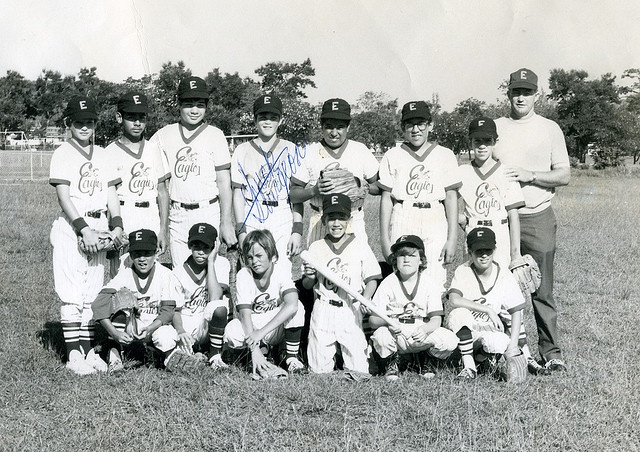Describe the objects in this image and their specific colors. I can see people in white, darkgray, gray, and black tones, people in white, lightgray, gray, darkgray, and black tones, people in white, darkgray, black, and gray tones, people in white, darkgray, black, and gray tones, and people in white, darkgray, black, and gray tones in this image. 